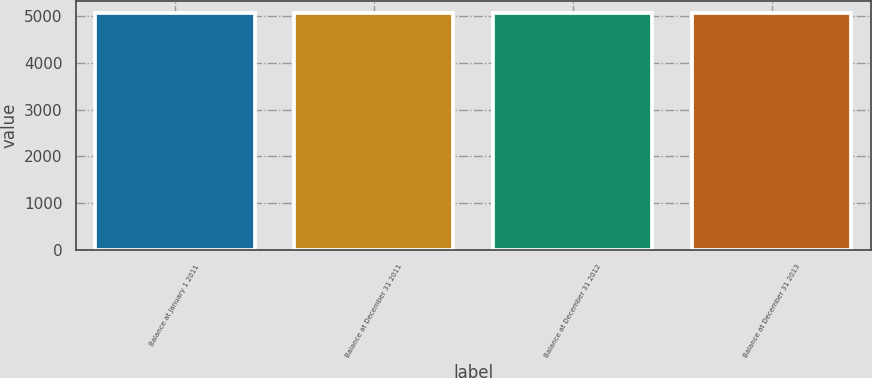Convert chart to OTSL. <chart><loc_0><loc_0><loc_500><loc_500><bar_chart><fcel>Balance at January 1 2011<fcel>Balance at December 31 2011<fcel>Balance at December 31 2012<fcel>Balance at December 31 2013<nl><fcel>5061<fcel>5061.1<fcel>5061.2<fcel>5061.3<nl></chart> 